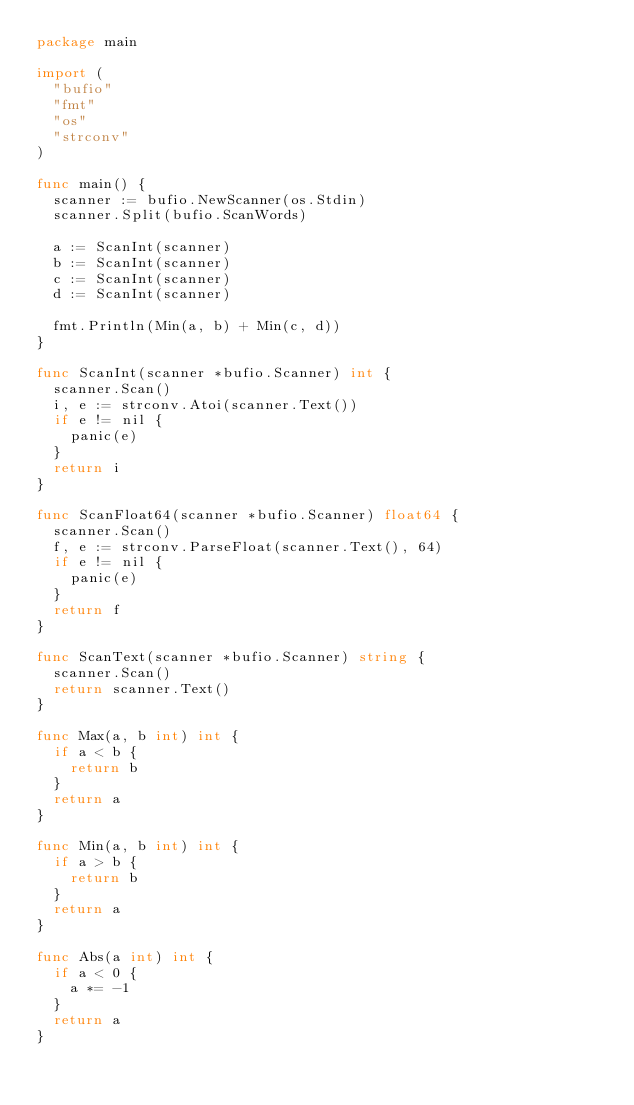<code> <loc_0><loc_0><loc_500><loc_500><_Go_>package main

import (
	"bufio"
	"fmt"
	"os"
	"strconv"
)

func main() {
	scanner := bufio.NewScanner(os.Stdin)
	scanner.Split(bufio.ScanWords)
	
	a := ScanInt(scanner)
	b := ScanInt(scanner)
	c := ScanInt(scanner)
	d := ScanInt(scanner)
	
	fmt.Println(Min(a, b) + Min(c, d))
}

func ScanInt(scanner *bufio.Scanner) int {
	scanner.Scan()
	i, e := strconv.Atoi(scanner.Text())
	if e != nil {
		panic(e)
	}
	return i
}

func ScanFloat64(scanner *bufio.Scanner) float64 {
	scanner.Scan()
	f, e := strconv.ParseFloat(scanner.Text(), 64)
	if e != nil {
		panic(e)
	}
	return f
}

func ScanText(scanner *bufio.Scanner) string {
	scanner.Scan()
	return scanner.Text()
}

func Max(a, b int) int {
	if a < b {
		return b
	}
	return a
}

func Min(a, b int) int {
	if a > b {
		return b
	}
	return a
}

func Abs(a int) int {
	if a < 0 {
		a *= -1
	}
	return a
}
 </code> 